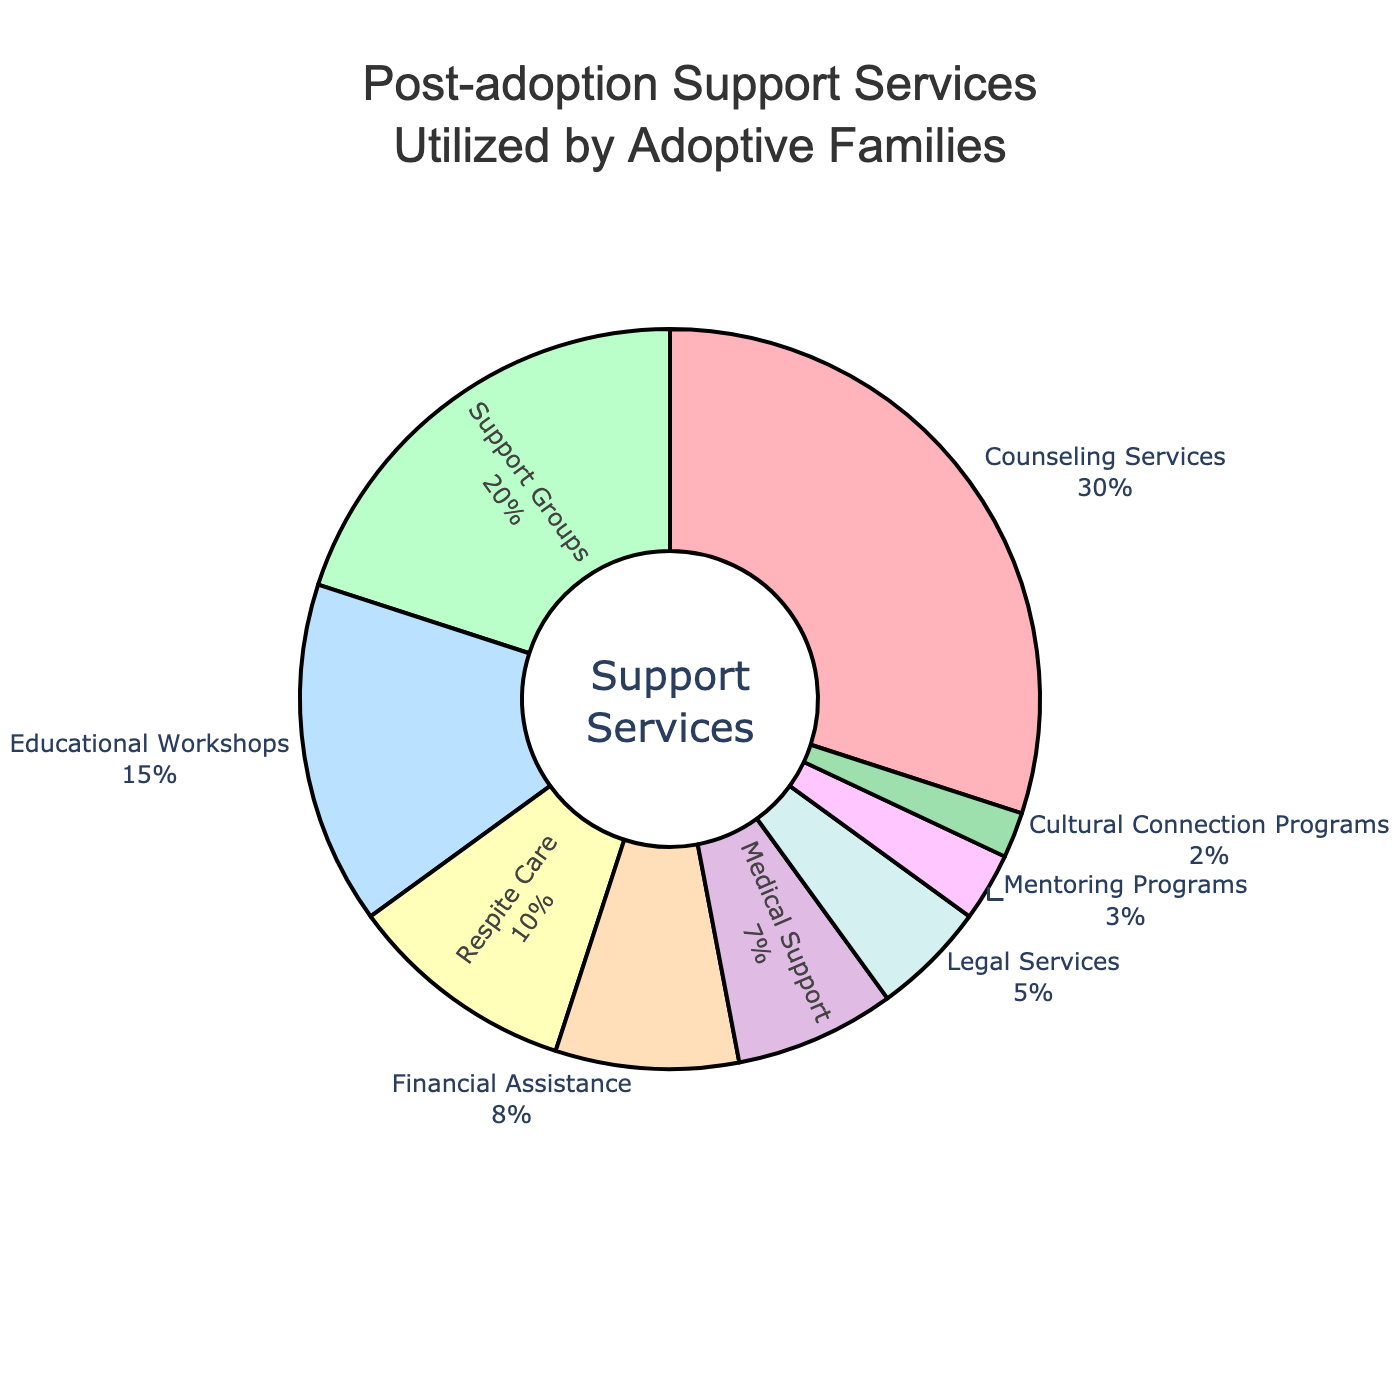Which support service category has the largest percentage? The pie chart indicates that Counseling Services has the largest section, representing 30% of the total.
Answer: Counseling Services Which two categories combined make up more than 40% of the total? Combining Counseling Services (30%) and Support Groups (20%) gives 30% + 20% = 50%, which is more than 40%.
Answer: Counseling Services and Support Groups What percentage difference is there between Educational Workshops and Respite Care? Educational Workshops represent 15%, and Respite Care represents 10%. The difference is calculated as 15% - 10% = 5%.
Answer: 5% How much more is Counseling Services utilized compared to Legal Services? Counseling Services is at 30%, while Legal Services is at 5%. Subtract 5% from 30% to get 30% - 5% = 25%.
Answer: 25% more Which support service category has the smallest percentage? The pie chart shows that Cultural Connection Programs have the smallest section, representing 2% of the total.
Answer: Cultural Connection Programs What is the combined percentage of Medical Support and Financial Assistance? Medical Support has 7%, and Financial Assistance has 8%. Adding these together gives 7% + 8% = 15%.
Answer: 15% Are there more families utilizing Educational Workshops or Financial Assistance? The pie chart shows Educational Workshops at 15% and Financial Assistance at 8%. So, Educational Workshops are utilized more.
Answer: Educational Workshops What is the total percentage of services not related to counseling, support groups, or educational workshops? Total percentage for services not related to these three categories = 100% - (30% + 20% + 15%) = 100% - 65% = 35%.
Answer: 35% How do the percentages of Respite Care and Medical Support compare? Respite Care is at 10%, and Medical Support is at 7%. So, Respite Care is utilized more.
Answer: Respite Care Which category's section in the pie chart is colored in green? The section for Support Groups is colored in green, as indicated by the green section in the pie chart.
Answer: Support Groups 